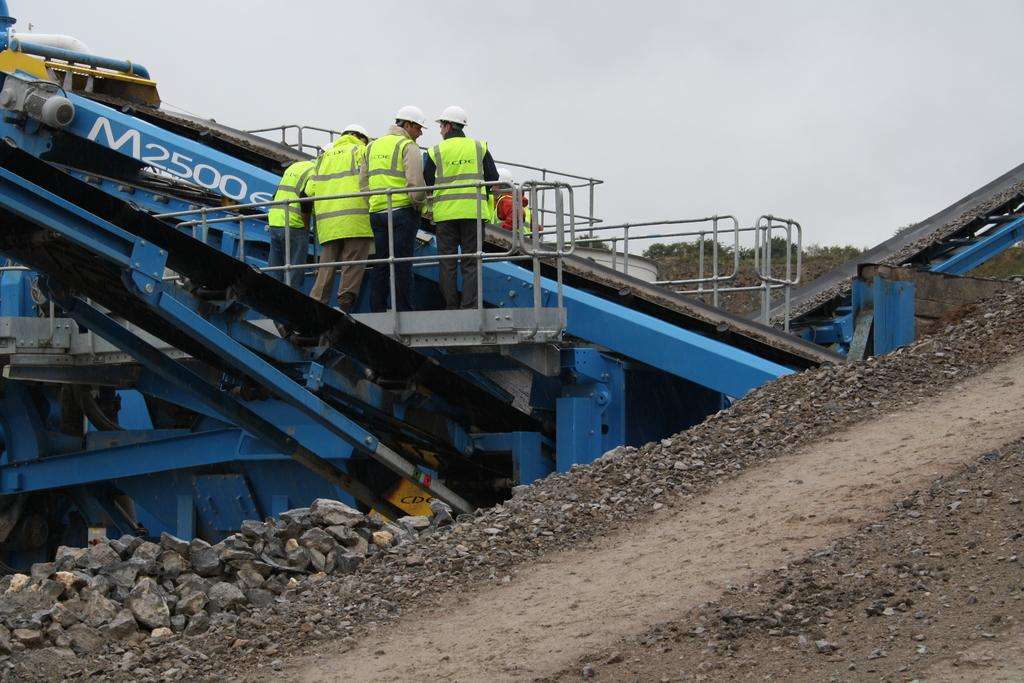<image>
Summarize the visual content of the image. the number 2500 that is on a blue arm 